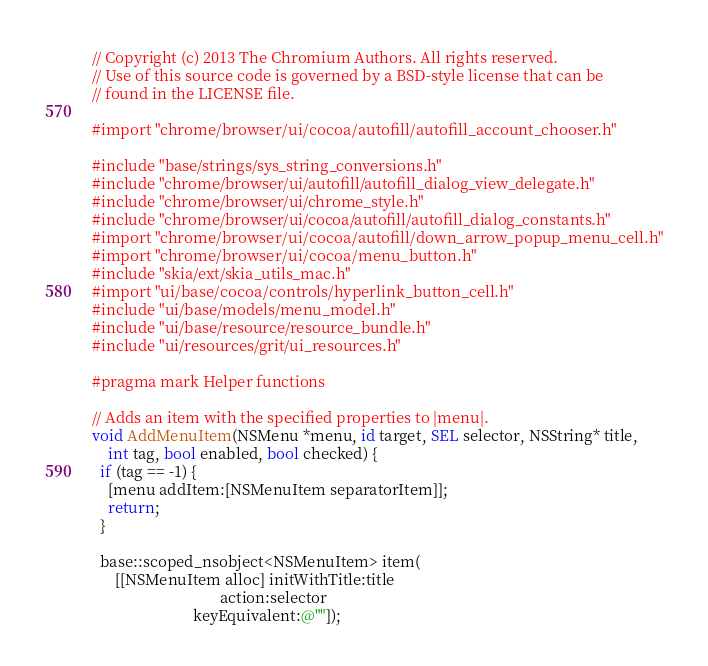Convert code to text. <code><loc_0><loc_0><loc_500><loc_500><_ObjectiveC_>// Copyright (c) 2013 The Chromium Authors. All rights reserved.
// Use of this source code is governed by a BSD-style license that can be
// found in the LICENSE file.

#import "chrome/browser/ui/cocoa/autofill/autofill_account_chooser.h"

#include "base/strings/sys_string_conversions.h"
#include "chrome/browser/ui/autofill/autofill_dialog_view_delegate.h"
#include "chrome/browser/ui/chrome_style.h"
#include "chrome/browser/ui/cocoa/autofill/autofill_dialog_constants.h"
#import "chrome/browser/ui/cocoa/autofill/down_arrow_popup_menu_cell.h"
#import "chrome/browser/ui/cocoa/menu_button.h"
#include "skia/ext/skia_utils_mac.h"
#import "ui/base/cocoa/controls/hyperlink_button_cell.h"
#include "ui/base/models/menu_model.h"
#include "ui/base/resource/resource_bundle.h"
#include "ui/resources/grit/ui_resources.h"

#pragma mark Helper functions

// Adds an item with the specified properties to |menu|.
void AddMenuItem(NSMenu *menu, id target, SEL selector, NSString* title,
    int tag, bool enabled, bool checked) {
  if (tag == -1) {
    [menu addItem:[NSMenuItem separatorItem]];
    return;
  }

  base::scoped_nsobject<NSMenuItem> item(
      [[NSMenuItem alloc] initWithTitle:title
                                 action:selector
                          keyEquivalent:@""]);</code> 